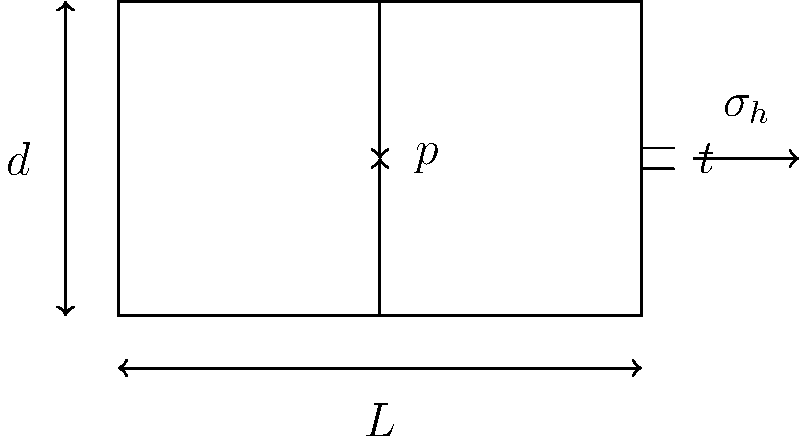A thin-walled cylinder with diameter $d$, length $L$, and wall thickness $t$ is subjected to internal pressure $p$. Given that $d = 500$ mm, $L = 1000$ mm, $t = 5$ mm, and $p = 2$ MPa, calculate the hoop stress $\sigma_h$ in the cylinder wall. Assume the cylinder material is steel with Young's modulus $E = 200$ GPa and Poisson's ratio $\nu = 0.3$. How does this stress compare to the yield strength of typical structural steel (250 MPa)? To solve this problem, we'll follow these steps:

1) For a thin-walled cylinder under internal pressure, the hoop stress $\sigma_h$ is given by:

   $$\sigma_h = \frac{pd}{2t}$$

   where $p$ is the internal pressure, $d$ is the diameter, and $t$ is the wall thickness.

2) Substituting the given values:

   $$\sigma_h = \frac{2 \text{ MPa} \times 500 \text{ mm}}{2 \times 5 \text{ mm}}$$

3) Simplifying:

   $$\sigma_h = \frac{1000}{10} = 100 \text{ MPa}$$

4) To compare with the yield strength:

   $100 \text{ MPa} < 250 \text{ MPa}$ (yield strength of typical structural steel)

   The hoop stress is less than half of the yield strength, indicating that the cylinder is operating within safe limits under the given conditions.

5) Note: We didn't need to use Young's modulus or Poisson's ratio in this calculation, as they are not required for determining hoop stress in a thin-walled cylinder under internal pressure.
Answer: 100 MPa, which is safe as it's less than half the typical yield strength of structural steel. 